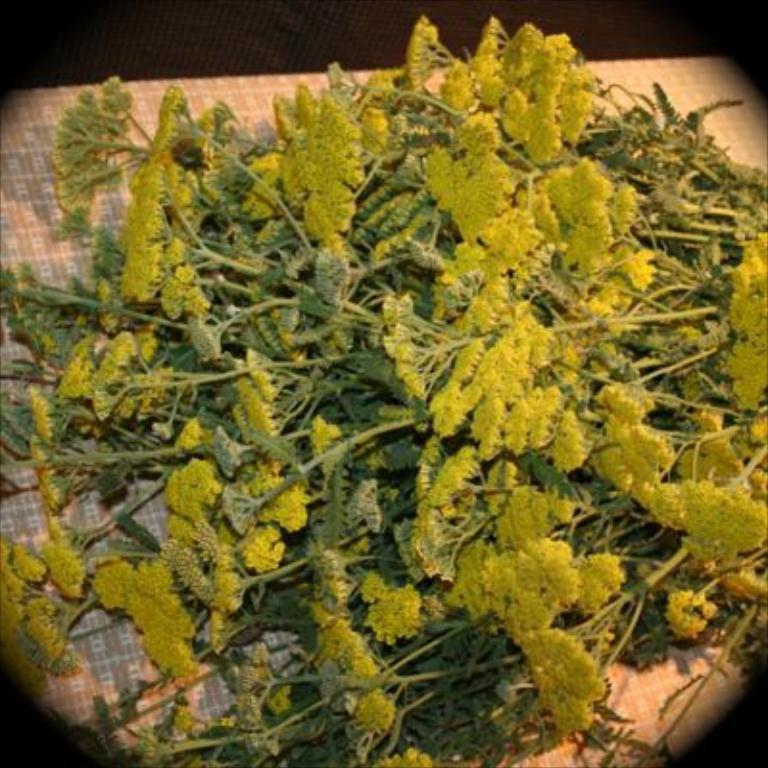What is in the foreground of the image? There are stems of a plant in the foreground of the image. Where are the stems located? The stems are on a table. What type of vacation is being advertised in the image? There is no vacation being advertised in the image; it only features stems of a plant on a table. 